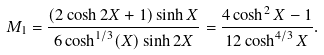Convert formula to latex. <formula><loc_0><loc_0><loc_500><loc_500>M _ { 1 } = \frac { ( 2 \cosh 2 X + 1 ) \sinh X } { 6 \cosh ^ { 1 / 3 } ( X ) \sinh 2 X } = \frac { 4 \cosh ^ { 2 } X - 1 } { 1 2 \cosh ^ { 4 / 3 } X } .</formula> 